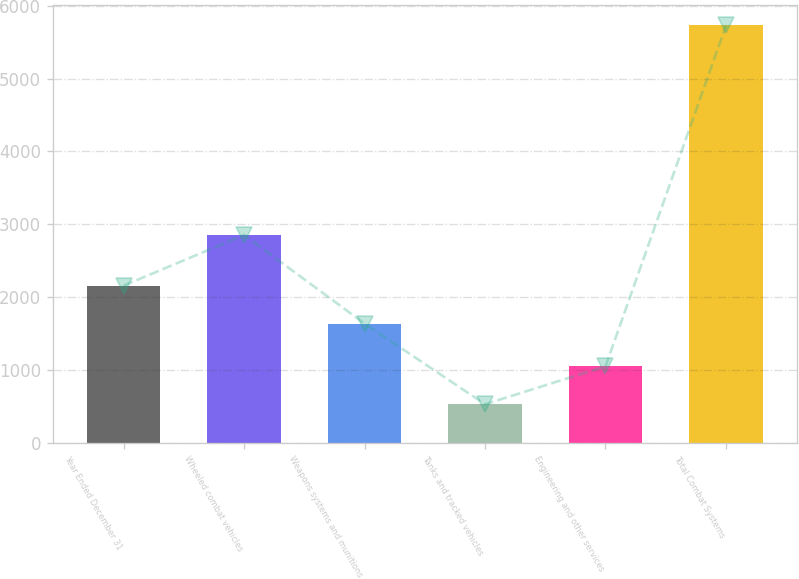Convert chart. <chart><loc_0><loc_0><loc_500><loc_500><bar_chart><fcel>Year Ended December 31<fcel>Wheeled combat vehicles<fcel>Weapons systems and munitions<fcel>Tanks and tracked vehicles<fcel>Engineering and other services<fcel>Total Combat Systems<nl><fcel>2155.6<fcel>2852<fcel>1635<fcel>526<fcel>1046.6<fcel>5732<nl></chart> 